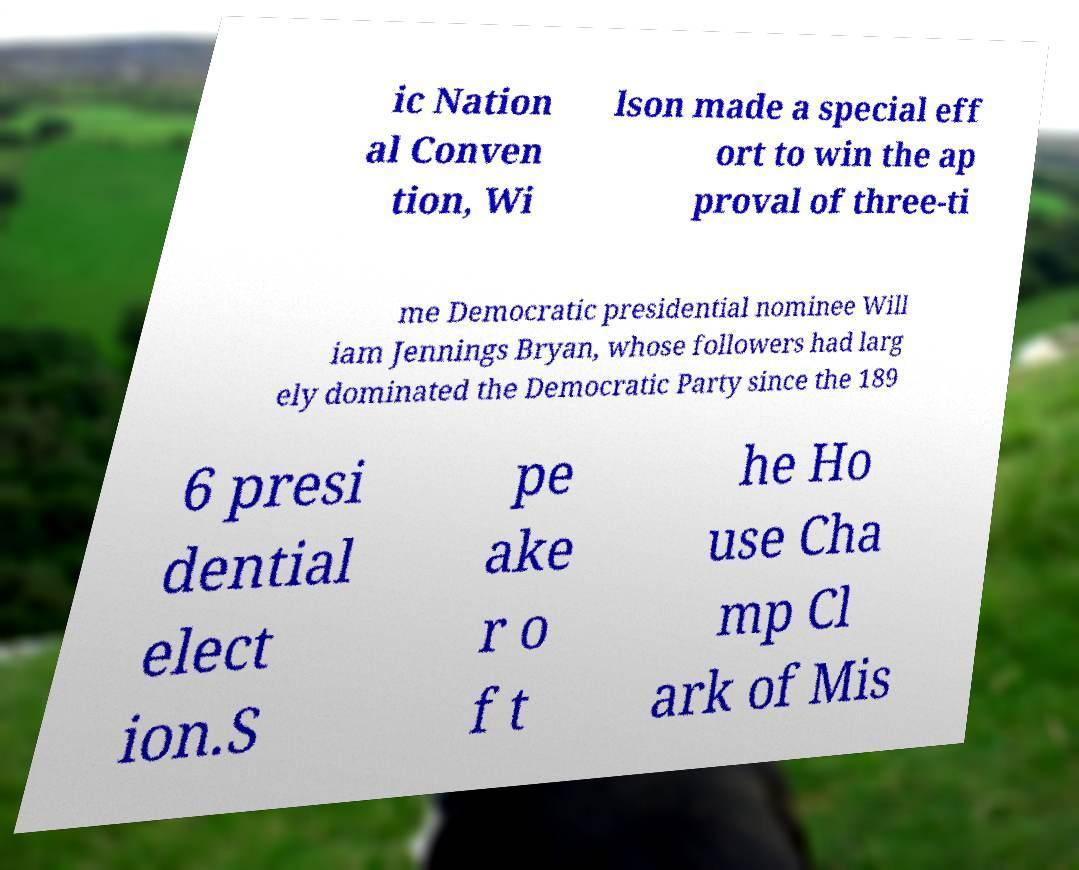For documentation purposes, I need the text within this image transcribed. Could you provide that? ic Nation al Conven tion, Wi lson made a special eff ort to win the ap proval of three-ti me Democratic presidential nominee Will iam Jennings Bryan, whose followers had larg ely dominated the Democratic Party since the 189 6 presi dential elect ion.S pe ake r o f t he Ho use Cha mp Cl ark of Mis 